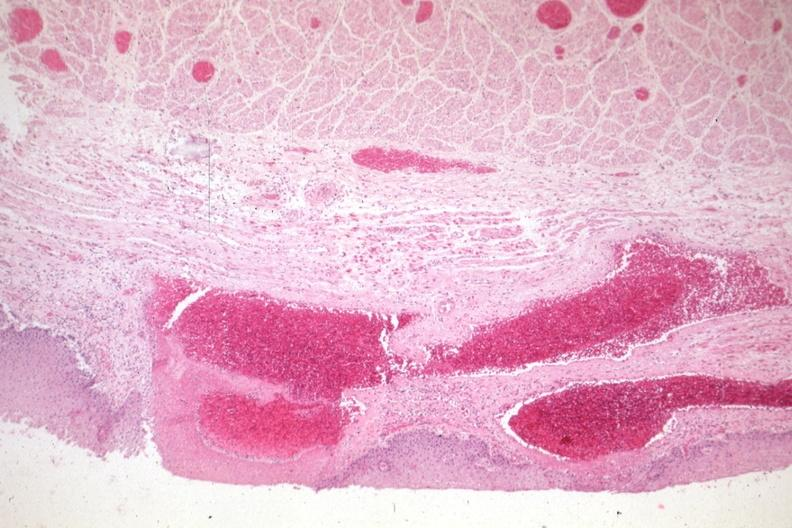s gastrointestinal present?
Answer the question using a single word or phrase. Yes 